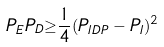<formula> <loc_0><loc_0><loc_500><loc_500>P _ { E } P _ { D } { \geq } \frac { 1 } { 4 } ( P _ { I D P } - P _ { I } ) ^ { 2 }</formula> 